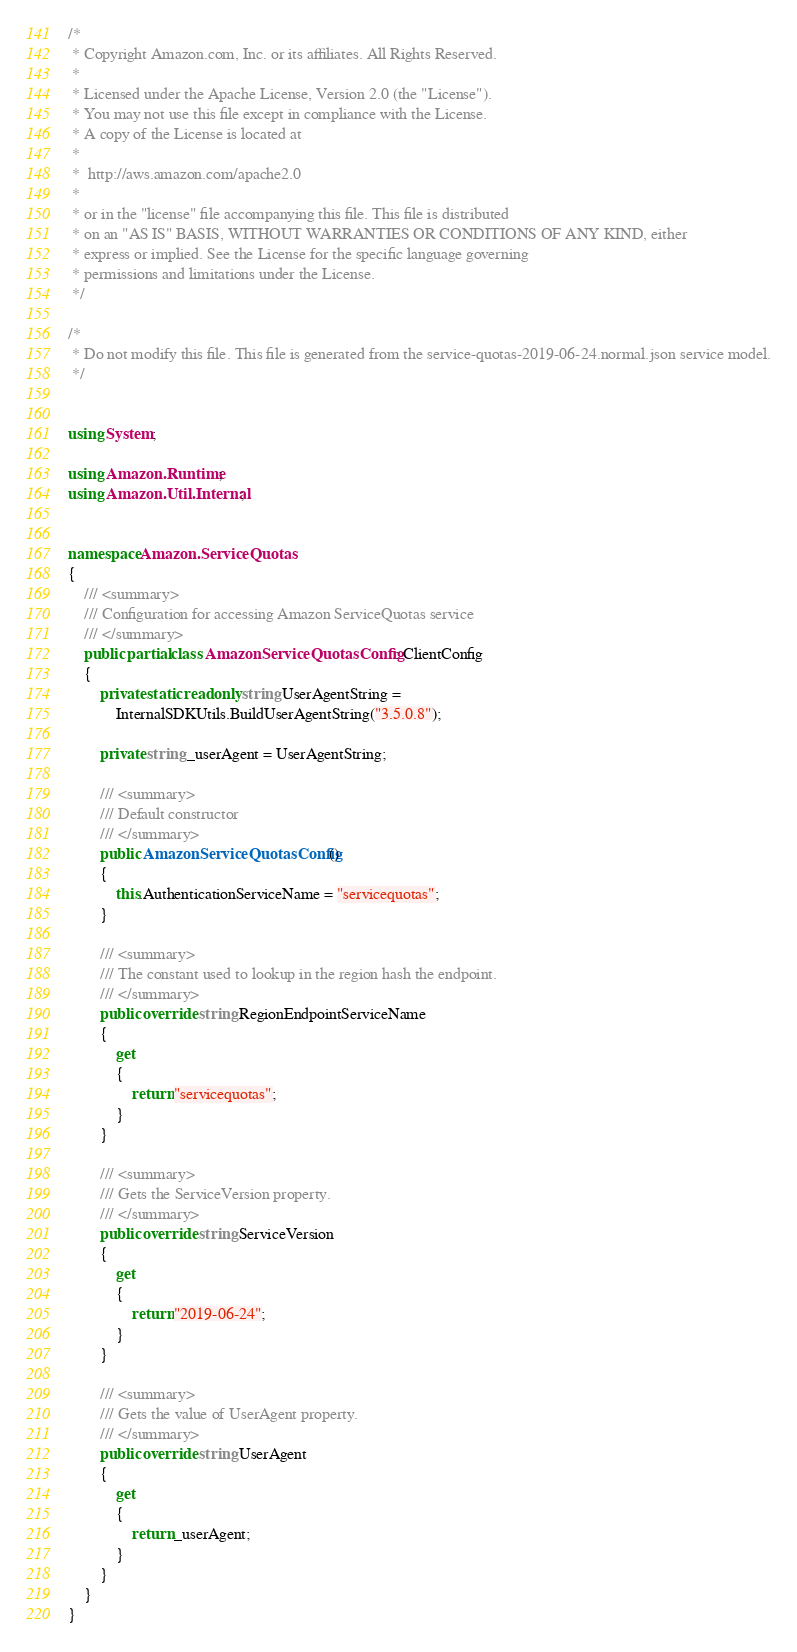<code> <loc_0><loc_0><loc_500><loc_500><_C#_>/*
 * Copyright Amazon.com, Inc. or its affiliates. All Rights Reserved.
 * 
 * Licensed under the Apache License, Version 2.0 (the "License").
 * You may not use this file except in compliance with the License.
 * A copy of the License is located at
 * 
 *  http://aws.amazon.com/apache2.0
 * 
 * or in the "license" file accompanying this file. This file is distributed
 * on an "AS IS" BASIS, WITHOUT WARRANTIES OR CONDITIONS OF ANY KIND, either
 * express or implied. See the License for the specific language governing
 * permissions and limitations under the License.
 */

/*
 * Do not modify this file. This file is generated from the service-quotas-2019-06-24.normal.json service model.
 */


using System;

using Amazon.Runtime;
using Amazon.Util.Internal;


namespace Amazon.ServiceQuotas
{
    /// <summary>
    /// Configuration for accessing Amazon ServiceQuotas service
    /// </summary>
    public partial class AmazonServiceQuotasConfig : ClientConfig
    {
        private static readonly string UserAgentString =
            InternalSDKUtils.BuildUserAgentString("3.5.0.8");

        private string _userAgent = UserAgentString;

        /// <summary>
        /// Default constructor
        /// </summary>
        public AmazonServiceQuotasConfig()
        {
            this.AuthenticationServiceName = "servicequotas";
        }

        /// <summary>
        /// The constant used to lookup in the region hash the endpoint.
        /// </summary>
        public override string RegionEndpointServiceName
        {
            get
            {
                return "servicequotas";
            }
        }

        /// <summary>
        /// Gets the ServiceVersion property.
        /// </summary>
        public override string ServiceVersion
        {
            get
            {
                return "2019-06-24";
            }
        }

        /// <summary>
        /// Gets the value of UserAgent property.
        /// </summary>
        public override string UserAgent
        {
            get
            {
                return _userAgent;
            }
        }
    }
}</code> 